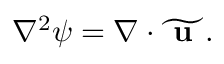Convert formula to latex. <formula><loc_0><loc_0><loc_500><loc_500>\begin{array} { r } { \nabla ^ { 2 } \psi = \nabla \cdot \widetilde { u } . } \end{array}</formula> 